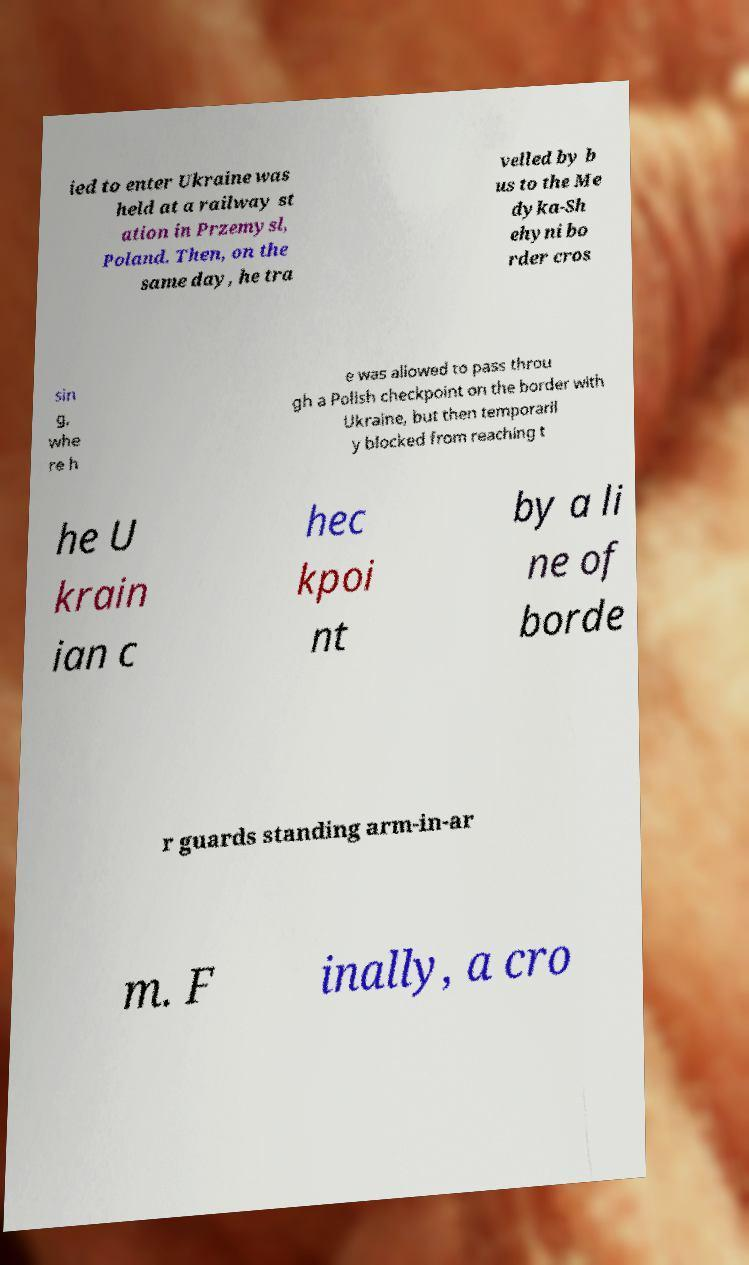Please identify and transcribe the text found in this image. ied to enter Ukraine was held at a railway st ation in Przemysl, Poland. Then, on the same day, he tra velled by b us to the Me dyka-Sh ehyni bo rder cros sin g, whe re h e was allowed to pass throu gh a Polish checkpoint on the border with Ukraine, but then temporaril y blocked from reaching t he U krain ian c hec kpoi nt by a li ne of borde r guards standing arm-in-ar m. F inally, a cro 